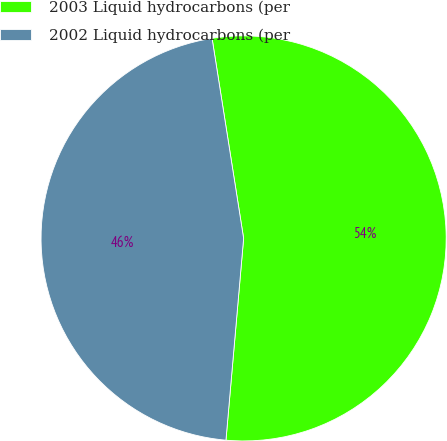<chart> <loc_0><loc_0><loc_500><loc_500><pie_chart><fcel>2003 Liquid hydrocarbons (per<fcel>2002 Liquid hydrocarbons (per<nl><fcel>53.88%<fcel>46.12%<nl></chart> 